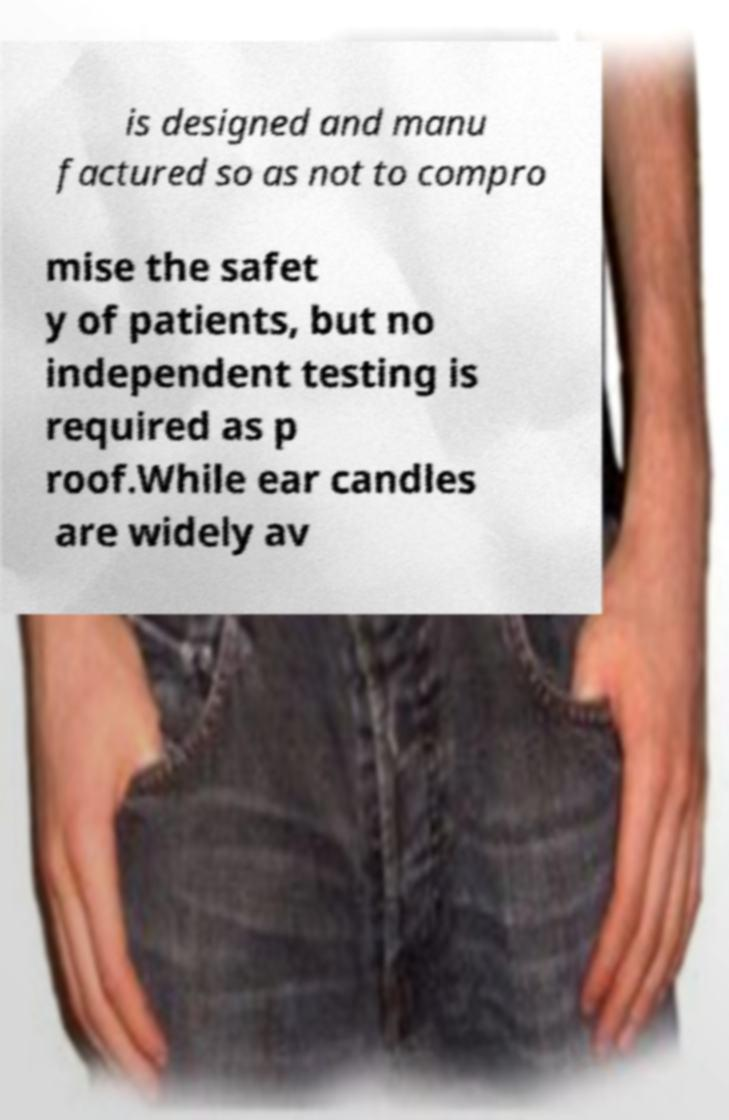For documentation purposes, I need the text within this image transcribed. Could you provide that? is designed and manu factured so as not to compro mise the safet y of patients, but no independent testing is required as p roof.While ear candles are widely av 